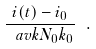Convert formula to latex. <formula><loc_0><loc_0><loc_500><loc_500>\frac { i ( t ) - i _ { 0 } } { \ a v k N _ { 0 } k _ { 0 } } \ .</formula> 